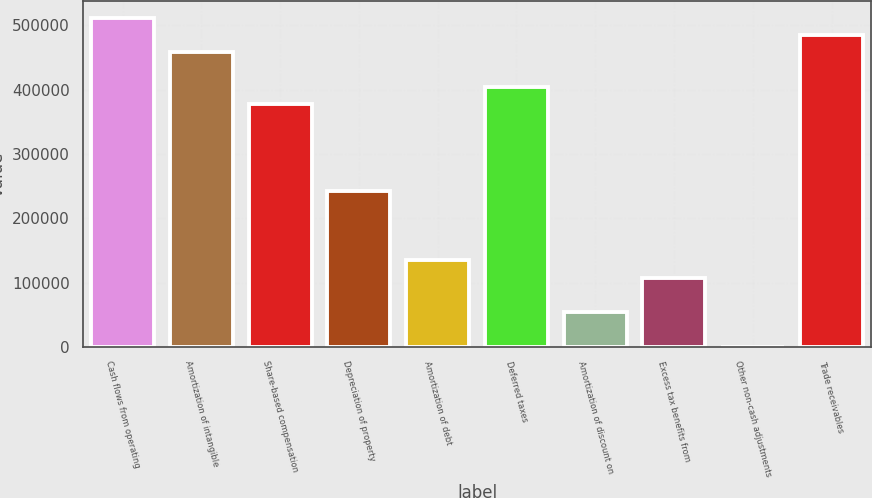<chart> <loc_0><loc_0><loc_500><loc_500><bar_chart><fcel>Cash flows from operating<fcel>Amortization of intangible<fcel>Share-based compensation<fcel>Depreciation of property<fcel>Amortization of debt<fcel>Deferred taxes<fcel>Amortization of discount on<fcel>Excess tax benefits from<fcel>Other non-cash adjustments<fcel>Trade receivables<nl><fcel>511899<fcel>458016<fcel>377190<fcel>242481<fcel>134714<fcel>404132<fcel>53888.6<fcel>107772<fcel>5<fcel>484957<nl></chart> 